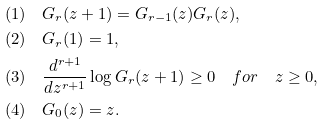Convert formula to latex. <formula><loc_0><loc_0><loc_500><loc_500>& ( 1 ) \quad G _ { r } ( z + 1 ) = G _ { r - 1 } ( z ) G _ { r } ( z ) , \\ & ( 2 ) \quad G _ { r } ( 1 ) = 1 , \\ & ( 3 ) \quad \frac { d ^ { r + 1 } } { d z ^ { r + 1 } } \log G _ { r } ( z + 1 ) \geq 0 \quad f o r \quad z \geq 0 , \\ & ( 4 ) \quad G _ { 0 } ( z ) = z .</formula> 